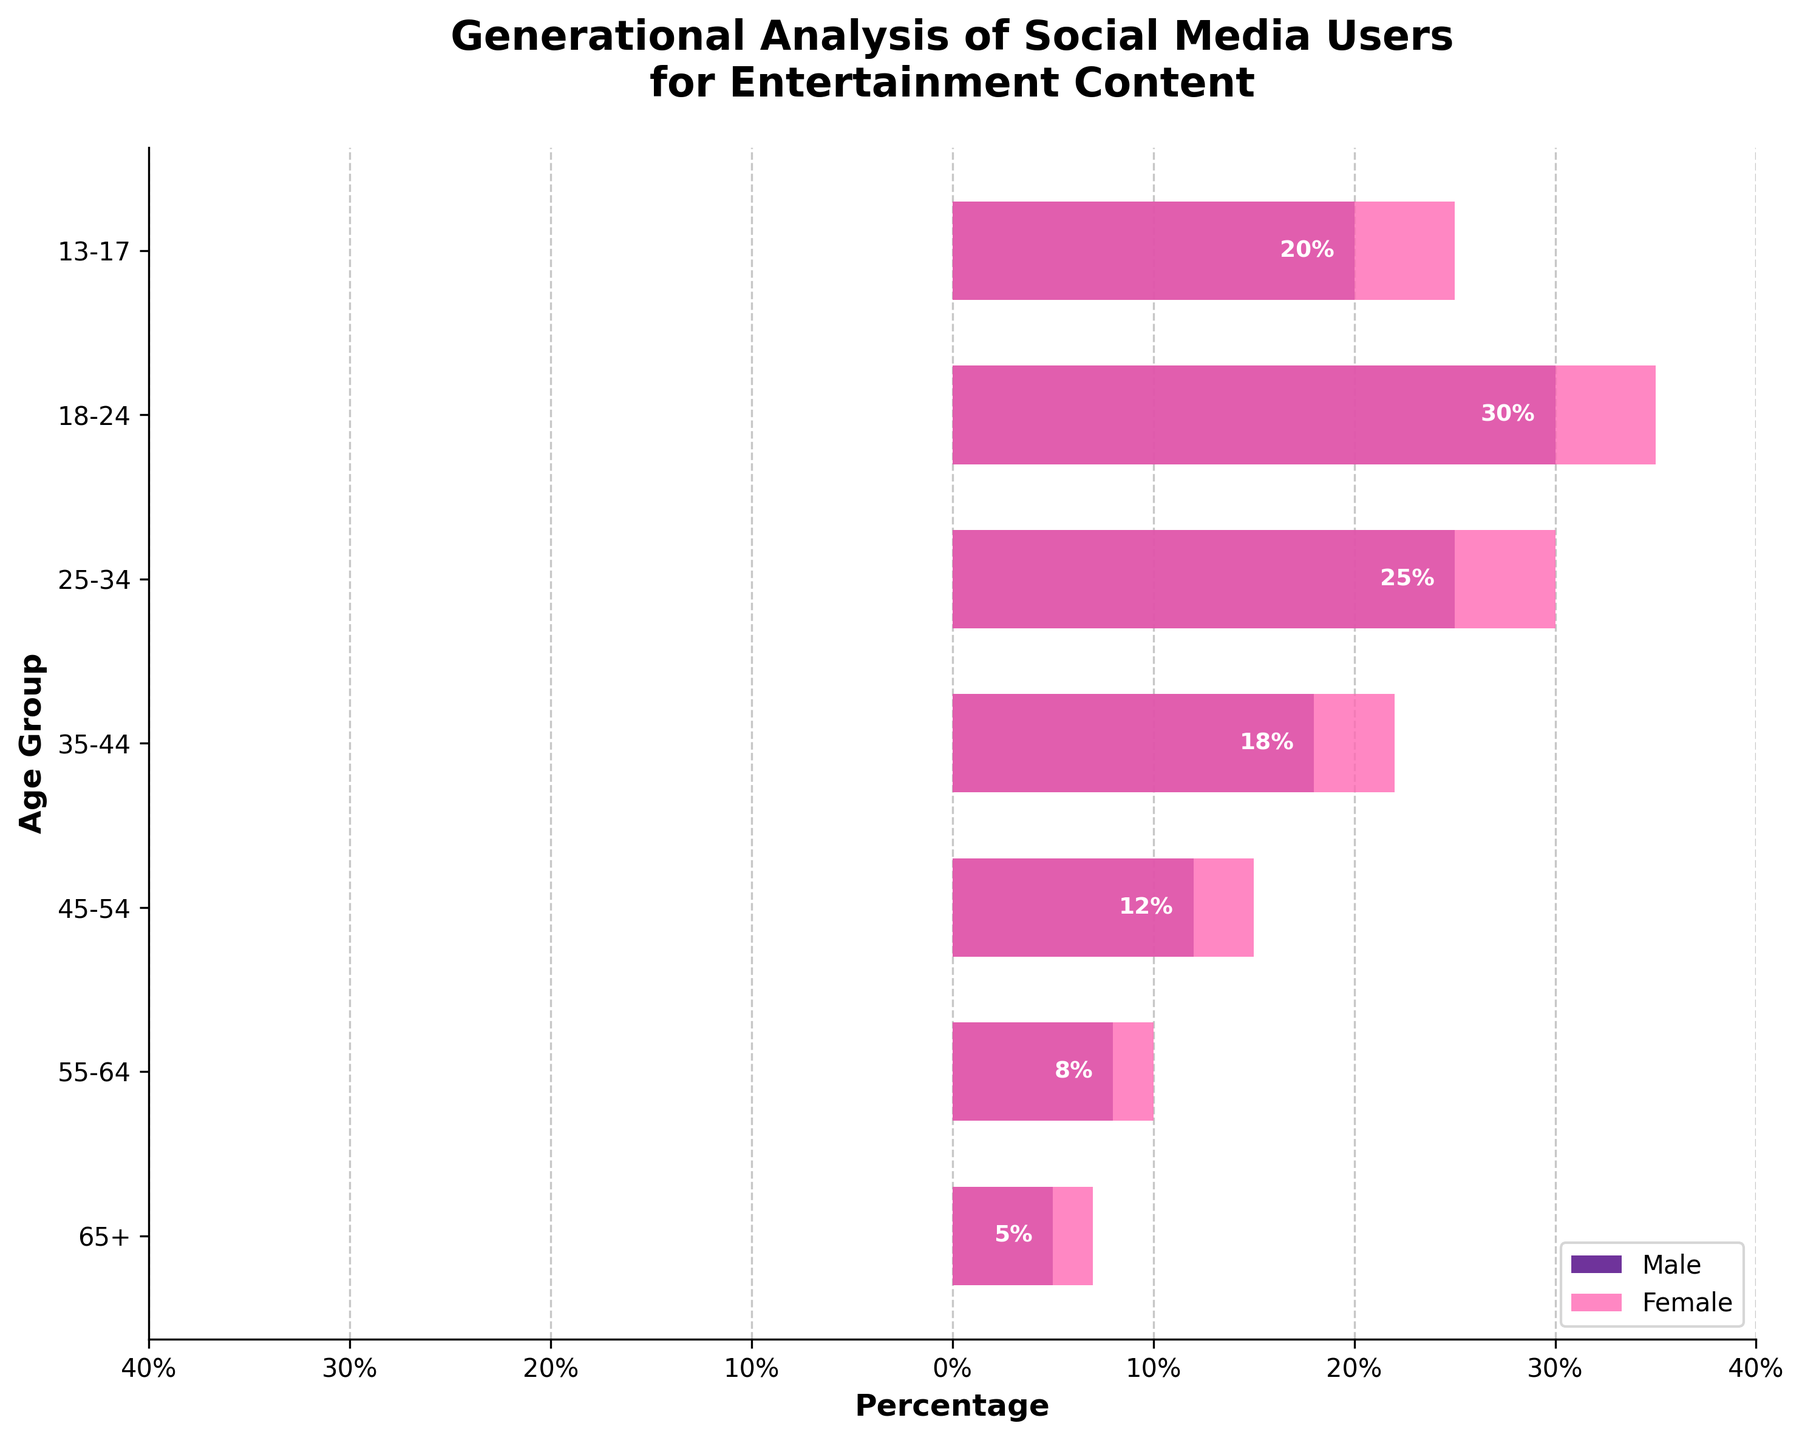What is the title of the figure? The title is usually located at the top of the figure and describes the main topic of the visualization. It reads "Generational Analysis of Social Media Users for Entertainment Content."
Answer: Generational Analysis of Social Media Users for Entertainment Content What do the x-axis labels represent? The x-axis labels show the percentage of social media platform users for entertainment content, separated into negative values for males and positive values for females. The ticks are marked every 10%.
Answer: Percentage Which age group has the highest percentage of male users? Looking at the horizontal bars on the left, the age group with the longest bar (most negative value) represents the highest percentage. The age group 18-24 has the highest negative value.
Answer: 18-24 Which age group has the highest percentage of female users? Observing the horizontal bars on the right, the age group with the longest bar represents the highest percentage. The 18-24 age group shows the highest positive value.
Answer: 18-24 How do the percentages of male and female users among the 35-44 age group compare? The height of the bars for the 35-44 age group shows us the percentages: -18% for males and 22% for females. Comparing their absolute values, females have a higher percentage.
Answer: Females have a higher percentage What is the difference in the percentage of male users between the 55-64 and 45-54 age groups? Subtract the value for the 55-64 group from the 45-54 group: (-12%) - (-8%) = -12% + 8% = -4%.
Answer: -4% Which age group shows the smallest gender gap in percentage terms? By calculating the difference between male and female percentages for each age group and comparing them, the smallest difference is for the 13-17 age group: abs(-20% - 25%) = 5%.
Answer: 13-17 What is the combined percentage of male and female users in the 25-34 age group? Add the absolute values of the male and female percentages: abs(-25%) + 30% = 25% + 30% = 55%.
Answer: 55% In which age group do male and female percentages differ the most? Calculate the difference for each age group and find the maximum: 
13-17: abs(-20% - 25%) = 5%
18-24: abs(-30% - 35%) = 5%
25-34: abs(-25% - 30%) = 5%
35-44: abs(-18% - 22%) = 4%
45-54: abs(-12% - 15%) = 3%
55-64: abs(-8% - 10%) = 2%
65+: abs(-5% - 7%) = 2%
The maximum difference is for the 18-24 age group.
Answer: 18-24 What is the total percentage of social media users, combining all age groups, for both genders? Sum of all male and female absolute percentages: 
Males: -5 - 8 - 12 - 18 - 25 - 30 - 20 = -118%
Females: 7 + 10 + 15 + 22 + 30 + 35 + 25 = 144%
Total: abs(-118%) + 144% = 118% + 144% = 262%.
Answer: 262% 